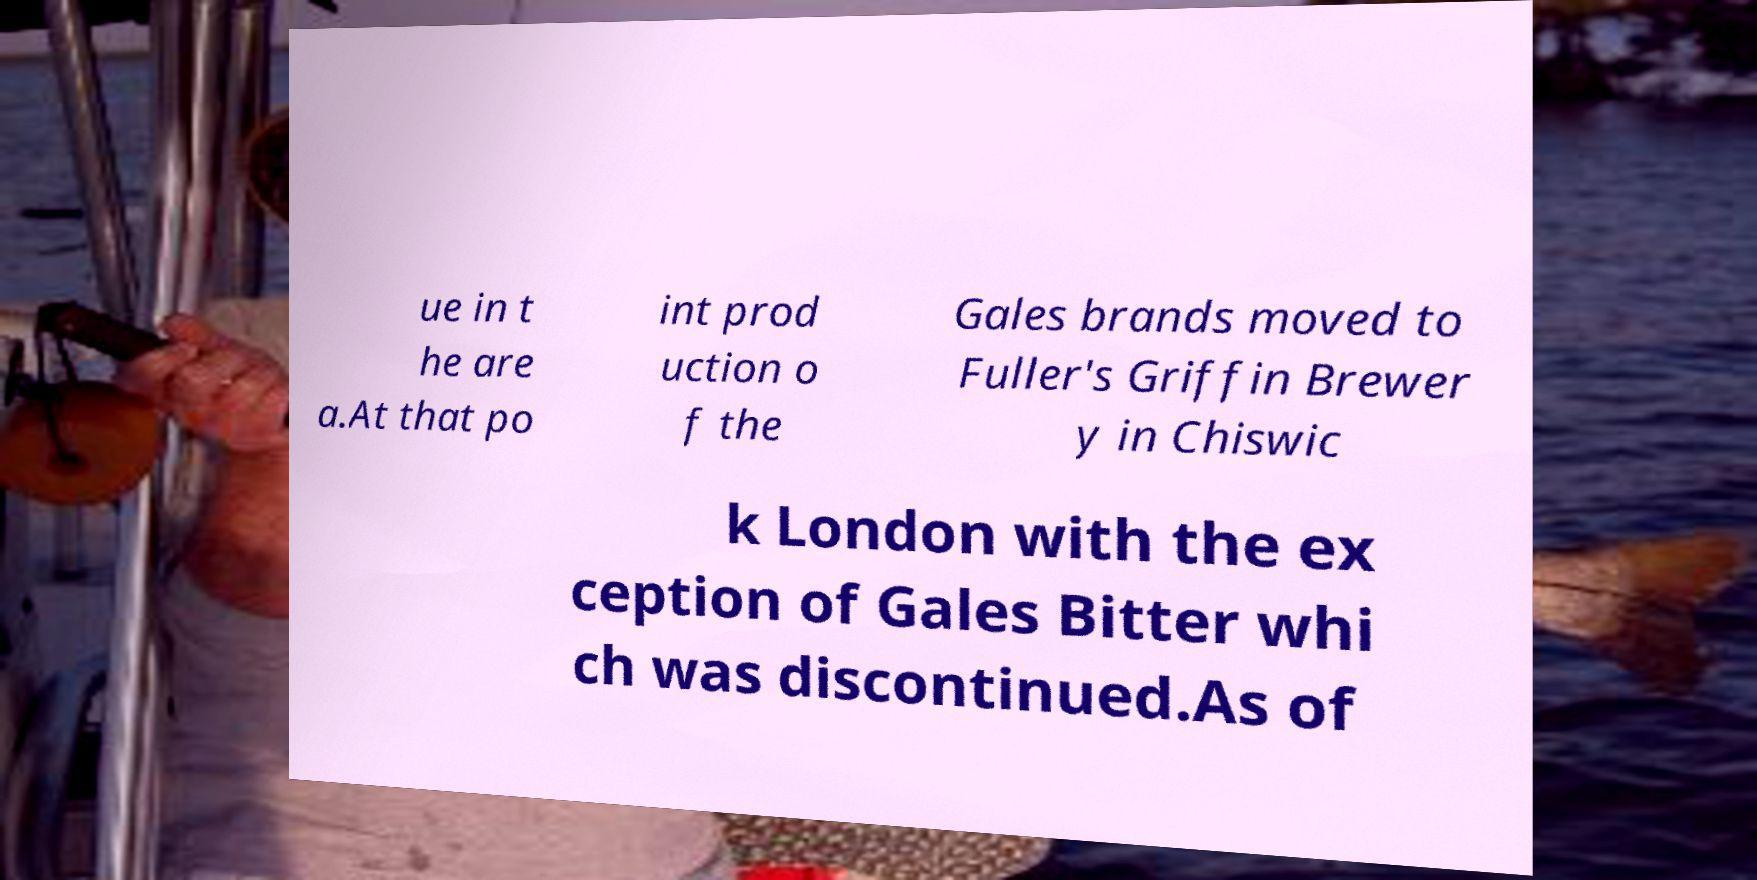Could you extract and type out the text from this image? ue in t he are a.At that po int prod uction o f the Gales brands moved to Fuller's Griffin Brewer y in Chiswic k London with the ex ception of Gales Bitter whi ch was discontinued.As of 